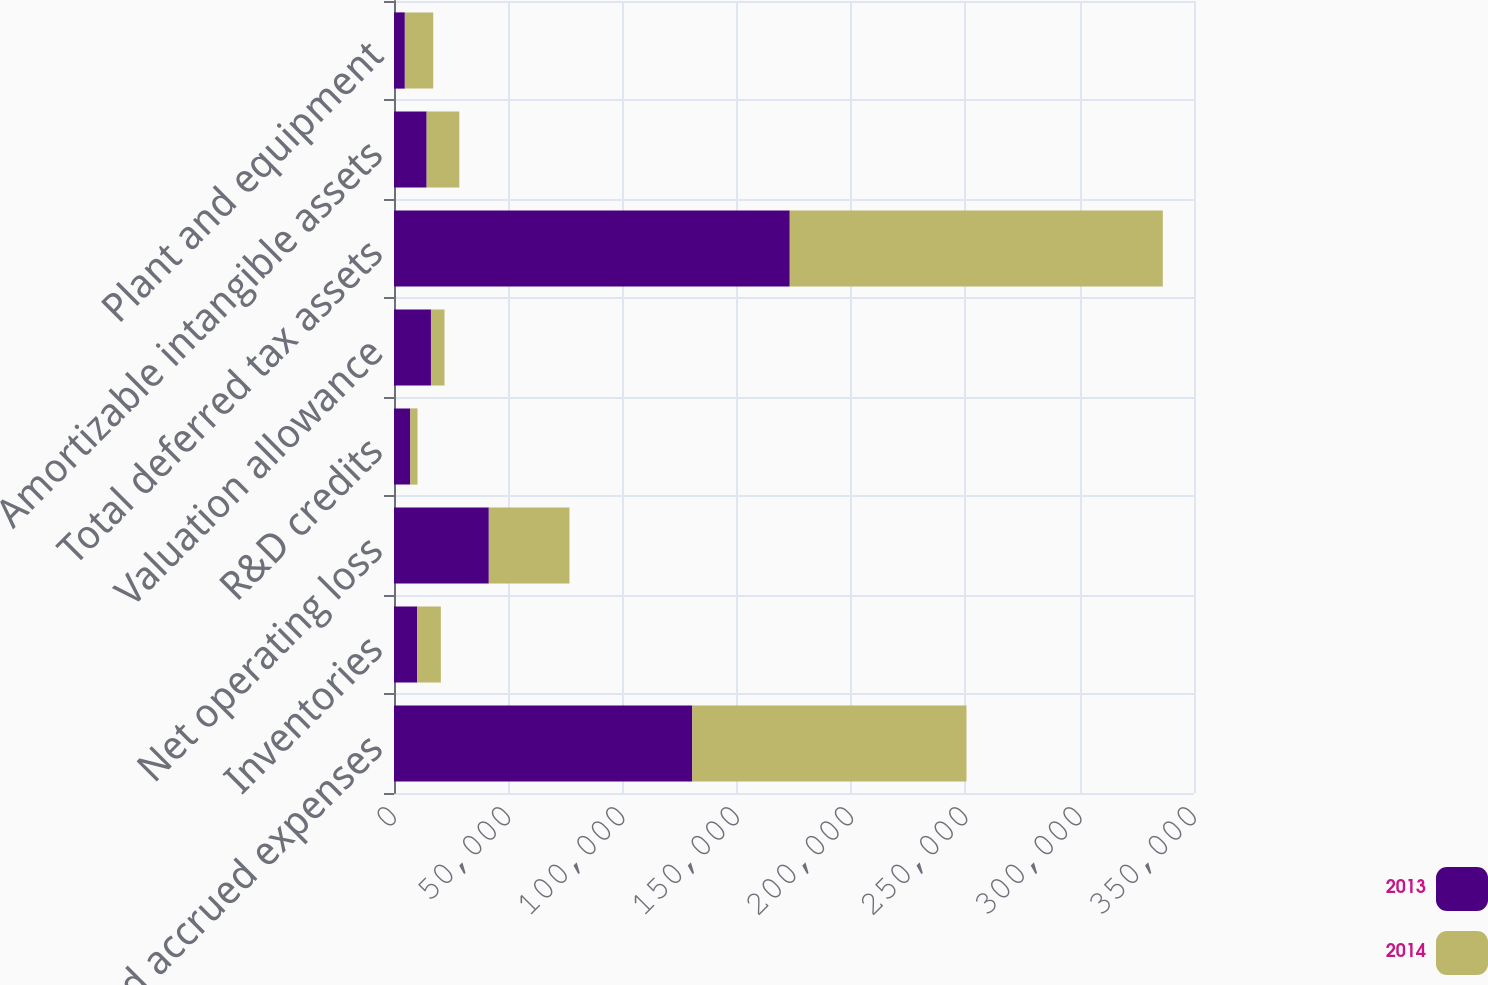<chart> <loc_0><loc_0><loc_500><loc_500><stacked_bar_chart><ecel><fcel>Reserves and accrued expenses<fcel>Inventories<fcel>Net operating loss<fcel>R&D credits<fcel>Valuation allowance<fcel>Total deferred tax assets<fcel>Amortizable intangible assets<fcel>Plant and equipment<nl><fcel>2013<fcel>130508<fcel>10186<fcel>41480<fcel>7145<fcel>16169<fcel>173150<fcel>14296<fcel>4741<nl><fcel>2014<fcel>119955<fcel>10315<fcel>35286<fcel>3134<fcel>5917<fcel>163198<fcel>14296<fcel>12423<nl></chart> 